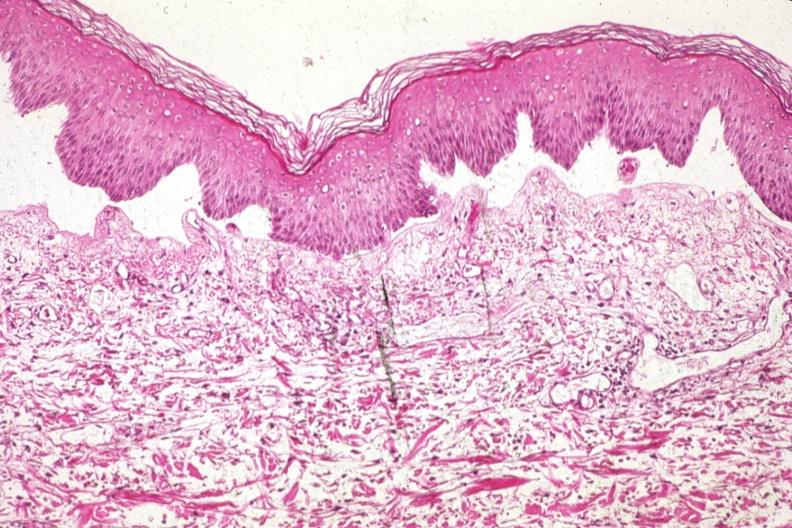what does this image show?
Answer the question using a single word or phrase. Med excellent example of epidermal separation gross of lesion is 907 